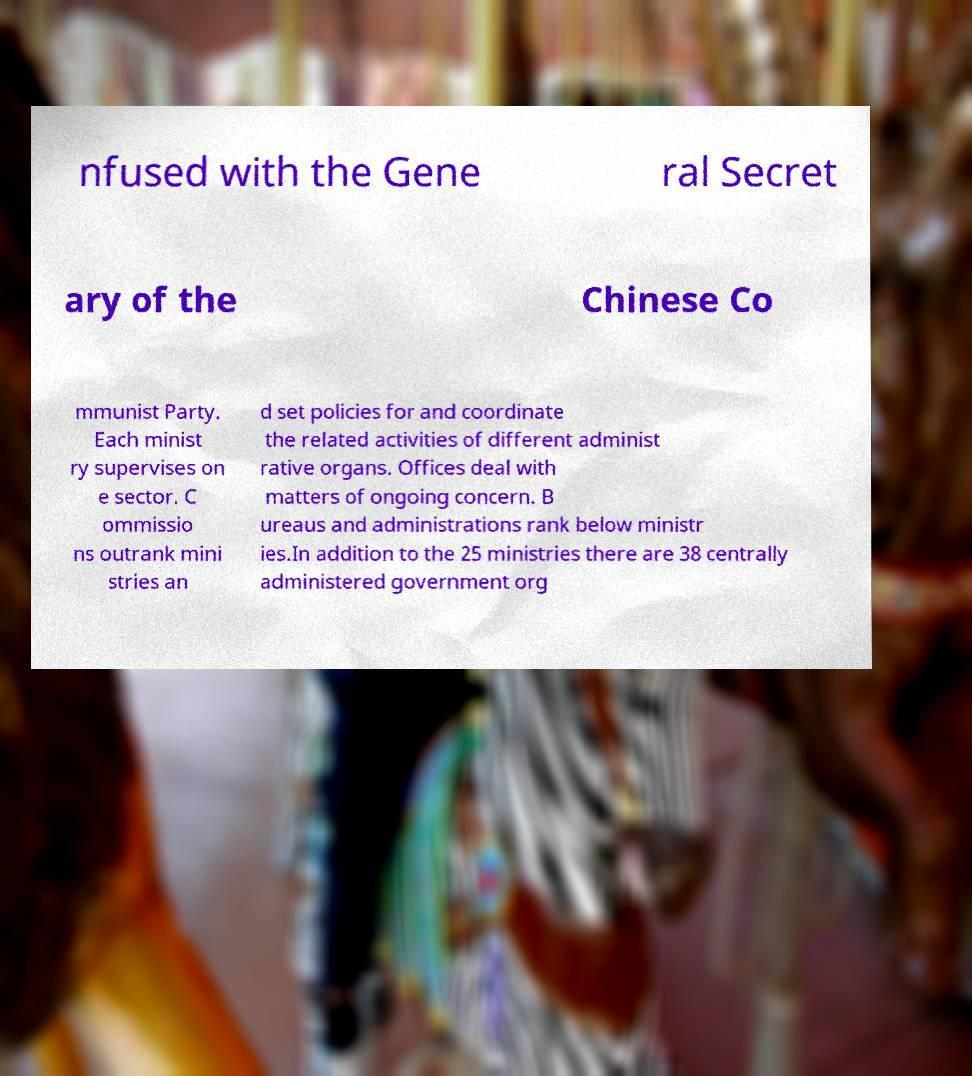Please read and relay the text visible in this image. What does it say? nfused with the Gene ral Secret ary of the Chinese Co mmunist Party. Each minist ry supervises on e sector. C ommissio ns outrank mini stries an d set policies for and coordinate the related activities of different administ rative organs. Offices deal with matters of ongoing concern. B ureaus and administrations rank below ministr ies.In addition to the 25 ministries there are 38 centrally administered government org 